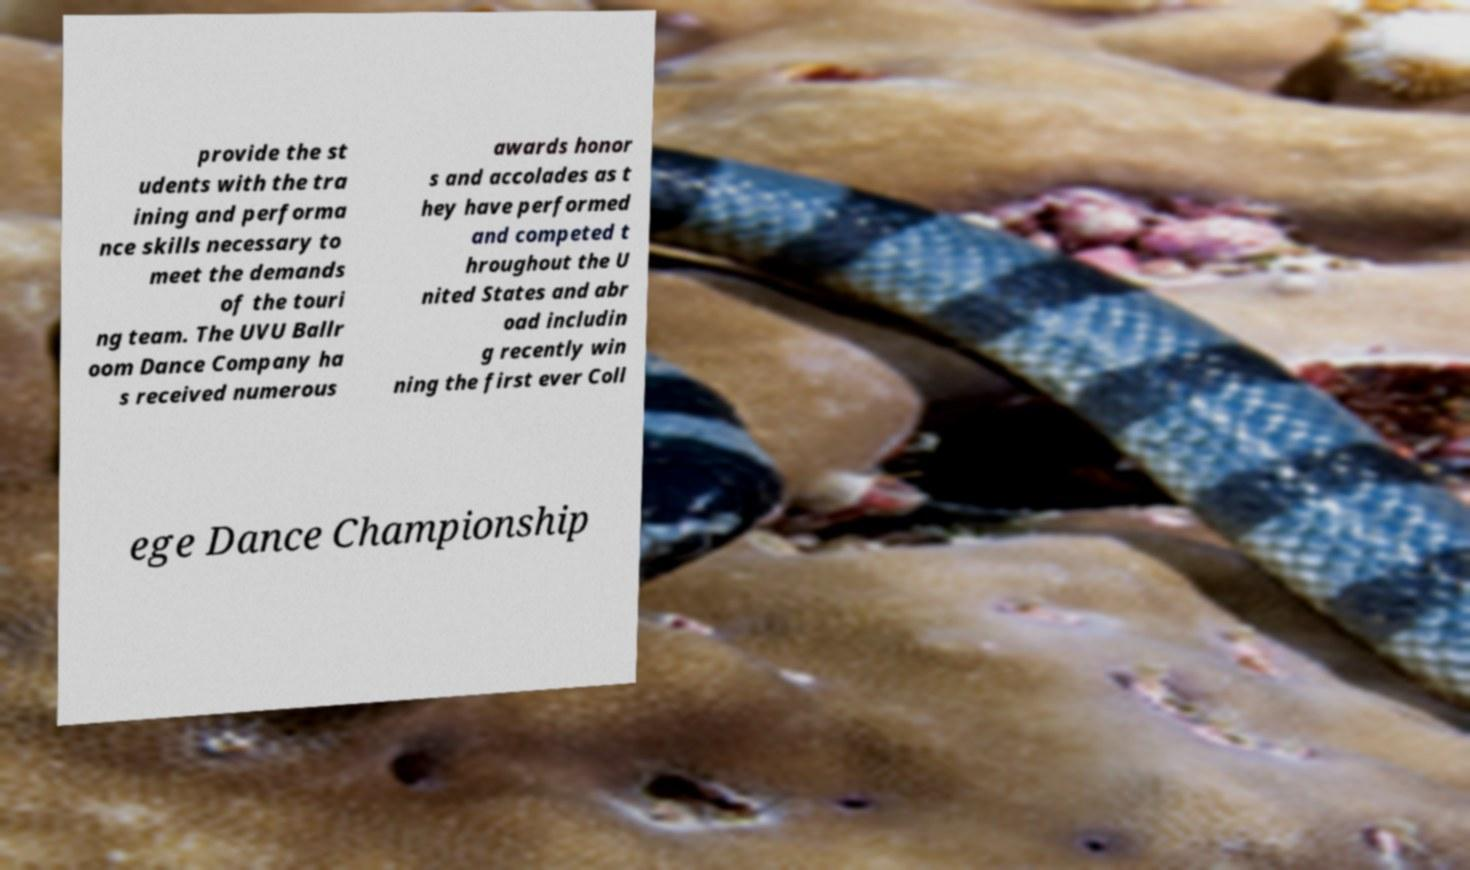Can you accurately transcribe the text from the provided image for me? provide the st udents with the tra ining and performa nce skills necessary to meet the demands of the touri ng team. The UVU Ballr oom Dance Company ha s received numerous awards honor s and accolades as t hey have performed and competed t hroughout the U nited States and abr oad includin g recently win ning the first ever Coll ege Dance Championship 